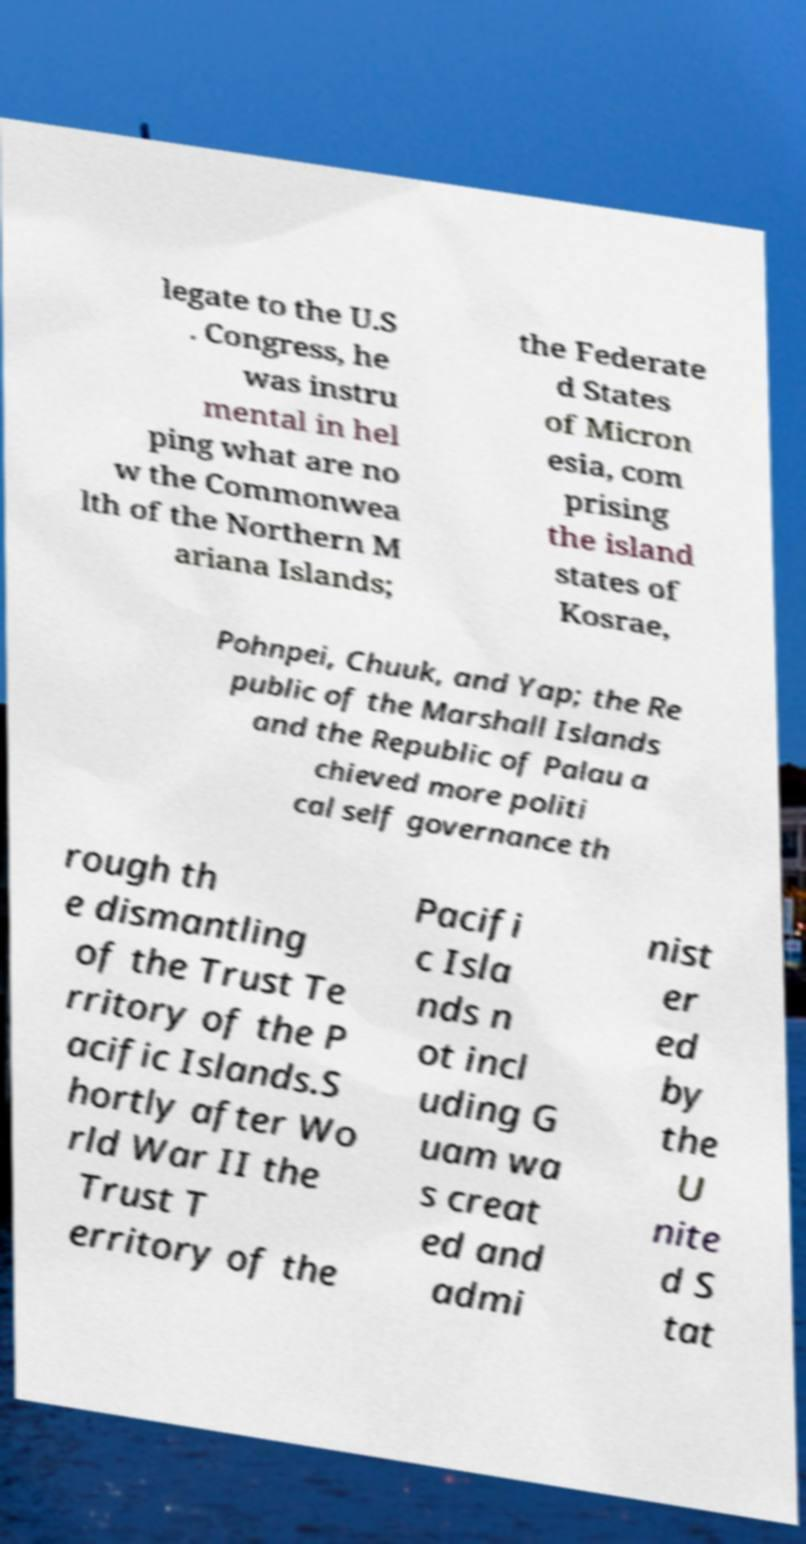Please identify and transcribe the text found in this image. legate to the U.S . Congress, he was instru mental in hel ping what are no w the Commonwea lth of the Northern M ariana Islands; the Federate d States of Micron esia, com prising the island states of Kosrae, Pohnpei, Chuuk, and Yap; the Re public of the Marshall Islands and the Republic of Palau a chieved more politi cal self governance th rough th e dismantling of the Trust Te rritory of the P acific Islands.S hortly after Wo rld War II the Trust T erritory of the Pacifi c Isla nds n ot incl uding G uam wa s creat ed and admi nist er ed by the U nite d S tat 